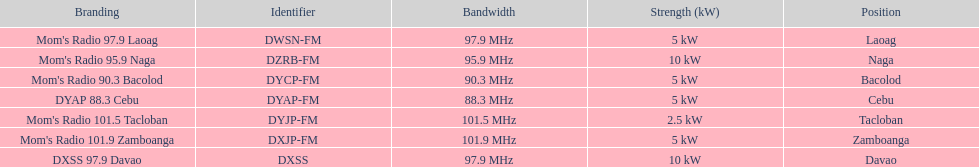How many stations have at least 5 kw or more listed in the power column? 6. 